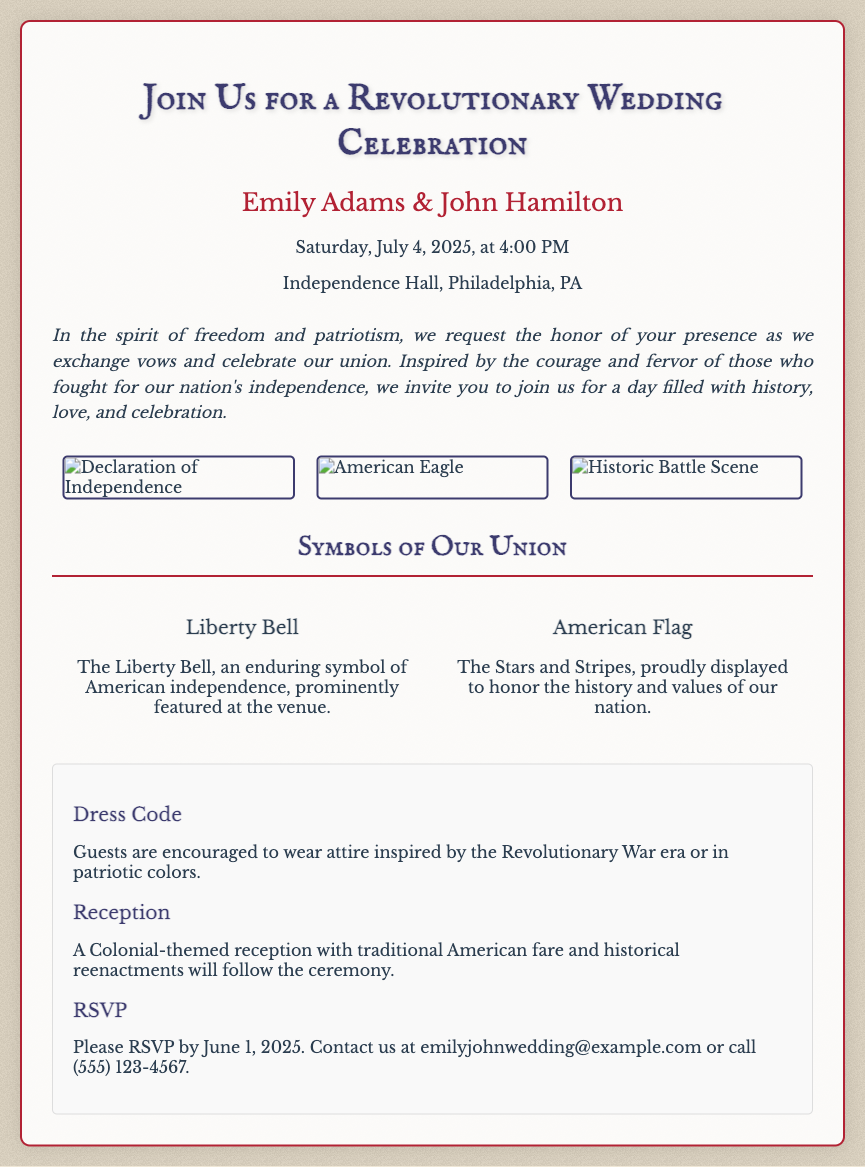What is the name of the couple? The couple's names are prominently displayed in the invitation.
Answer: Emily Adams & John Hamilton What is the wedding date? The date of the wedding is provided in the details section.
Answer: Saturday, July 4, 2025 Where is the wedding taking place? The location of the wedding is specified in the invitation details.
Answer: Independence Hall, Philadelphia, PA What is the dress code? The dress code information is outlined in the notes section of the invitation.
Answer: Revolutionary War era or patriotic colors What kind of reception will follow the ceremony? The reception details are mentioned in the notes section.
Answer: Colonial-themed reception with traditional American fare and historical reenactments 